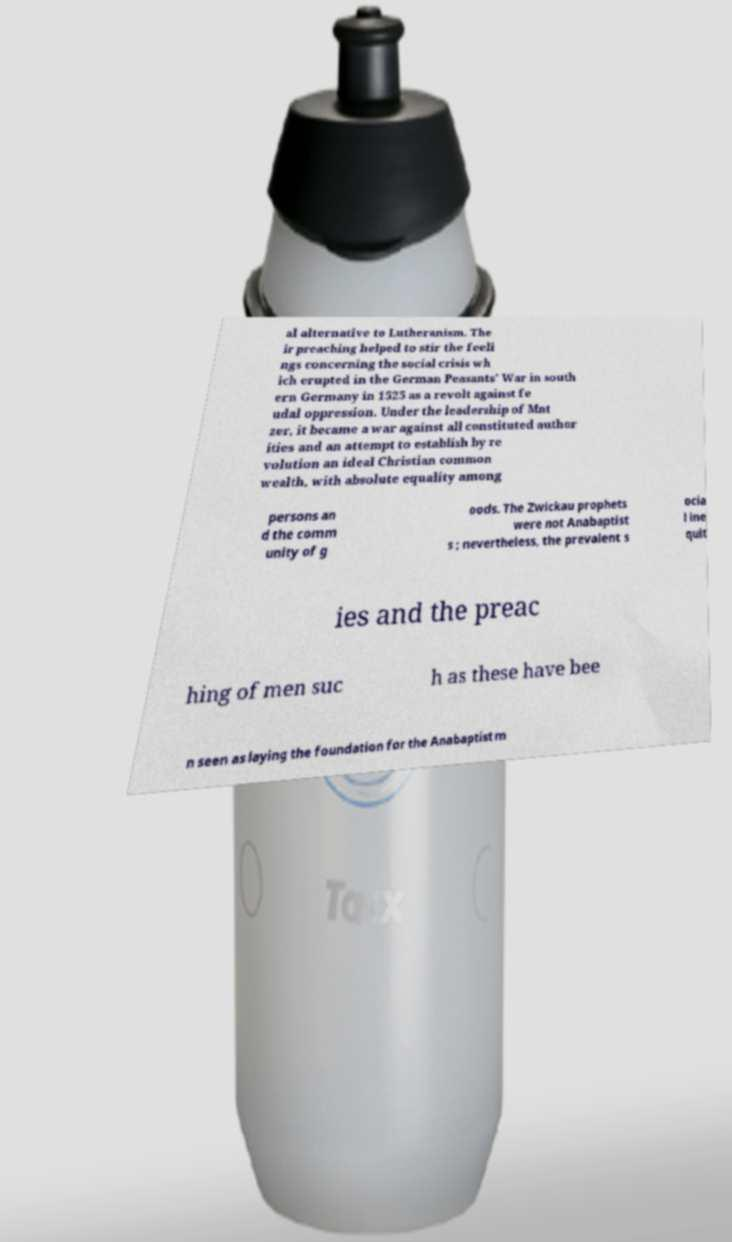Could you extract and type out the text from this image? al alternative to Lutheranism. The ir preaching helped to stir the feeli ngs concerning the social crisis wh ich erupted in the German Peasants' War in south ern Germany in 1525 as a revolt against fe udal oppression. Under the leadership of Mnt zer, it became a war against all constituted author ities and an attempt to establish by re volution an ideal Christian common wealth, with absolute equality among persons an d the comm unity of g oods. The Zwickau prophets were not Anabaptist s ; nevertheless, the prevalent s ocia l ine quit ies and the preac hing of men suc h as these have bee n seen as laying the foundation for the Anabaptist m 